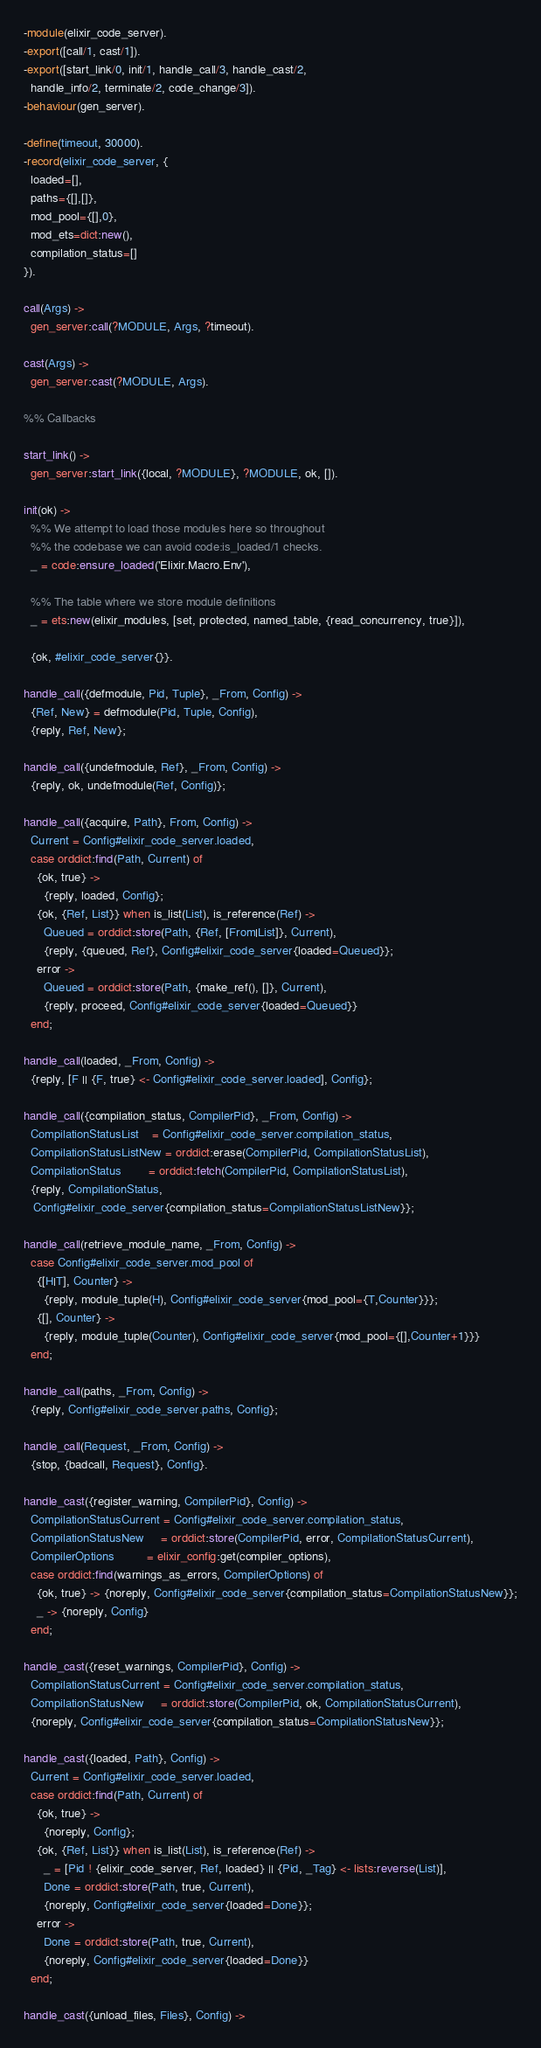Convert code to text. <code><loc_0><loc_0><loc_500><loc_500><_Erlang_>-module(elixir_code_server).
-export([call/1, cast/1]).
-export([start_link/0, init/1, handle_call/3, handle_cast/2,
  handle_info/2, terminate/2, code_change/3]).
-behaviour(gen_server).

-define(timeout, 30000).
-record(elixir_code_server, {
  loaded=[],
  paths={[],[]},
  mod_pool={[],0},
  mod_ets=dict:new(),
  compilation_status=[]
}).

call(Args) ->
  gen_server:call(?MODULE, Args, ?timeout).

cast(Args) ->
  gen_server:cast(?MODULE, Args).

%% Callbacks

start_link() ->
  gen_server:start_link({local, ?MODULE}, ?MODULE, ok, []).

init(ok) ->
  %% We attempt to load those modules here so throughout
  %% the codebase we can avoid code:is_loaded/1 checks.
  _ = code:ensure_loaded('Elixir.Macro.Env'),

  %% The table where we store module definitions
  _ = ets:new(elixir_modules, [set, protected, named_table, {read_concurrency, true}]),

  {ok, #elixir_code_server{}}.

handle_call({defmodule, Pid, Tuple}, _From, Config) ->
  {Ref, New} = defmodule(Pid, Tuple, Config),
  {reply, Ref, New};

handle_call({undefmodule, Ref}, _From, Config) ->
  {reply, ok, undefmodule(Ref, Config)};

handle_call({acquire, Path}, From, Config) ->
  Current = Config#elixir_code_server.loaded,
  case orddict:find(Path, Current) of
    {ok, true} ->
      {reply, loaded, Config};
    {ok, {Ref, List}} when is_list(List), is_reference(Ref) ->
      Queued = orddict:store(Path, {Ref, [From|List]}, Current),
      {reply, {queued, Ref}, Config#elixir_code_server{loaded=Queued}};
    error ->
      Queued = orddict:store(Path, {make_ref(), []}, Current),
      {reply, proceed, Config#elixir_code_server{loaded=Queued}}
  end;

handle_call(loaded, _From, Config) ->
  {reply, [F || {F, true} <- Config#elixir_code_server.loaded], Config};

handle_call({compilation_status, CompilerPid}, _From, Config) ->
  CompilationStatusList    = Config#elixir_code_server.compilation_status,
  CompilationStatusListNew = orddict:erase(CompilerPid, CompilationStatusList),
  CompilationStatus        = orddict:fetch(CompilerPid, CompilationStatusList),
  {reply, CompilationStatus,
   Config#elixir_code_server{compilation_status=CompilationStatusListNew}};

handle_call(retrieve_module_name, _From, Config) ->
  case Config#elixir_code_server.mod_pool of
    {[H|T], Counter} ->
      {reply, module_tuple(H), Config#elixir_code_server{mod_pool={T,Counter}}};
    {[], Counter} ->
      {reply, module_tuple(Counter), Config#elixir_code_server{mod_pool={[],Counter+1}}}
  end;

handle_call(paths, _From, Config) ->
  {reply, Config#elixir_code_server.paths, Config};

handle_call(Request, _From, Config) ->
  {stop, {badcall, Request}, Config}.

handle_cast({register_warning, CompilerPid}, Config) ->
  CompilationStatusCurrent = Config#elixir_code_server.compilation_status,
  CompilationStatusNew     = orddict:store(CompilerPid, error, CompilationStatusCurrent),
  CompilerOptions          = elixir_config:get(compiler_options),
  case orddict:find(warnings_as_errors, CompilerOptions) of
    {ok, true} -> {noreply, Config#elixir_code_server{compilation_status=CompilationStatusNew}};
    _ -> {noreply, Config}
  end;

handle_cast({reset_warnings, CompilerPid}, Config) ->
  CompilationStatusCurrent = Config#elixir_code_server.compilation_status,
  CompilationStatusNew     = orddict:store(CompilerPid, ok, CompilationStatusCurrent),
  {noreply, Config#elixir_code_server{compilation_status=CompilationStatusNew}};

handle_cast({loaded, Path}, Config) ->
  Current = Config#elixir_code_server.loaded,
  case orddict:find(Path, Current) of
    {ok, true} ->
      {noreply, Config};
    {ok, {Ref, List}} when is_list(List), is_reference(Ref) ->
      _ = [Pid ! {elixir_code_server, Ref, loaded} || {Pid, _Tag} <- lists:reverse(List)],
      Done = orddict:store(Path, true, Current),
      {noreply, Config#elixir_code_server{loaded=Done}};
    error ->
      Done = orddict:store(Path, true, Current),
      {noreply, Config#elixir_code_server{loaded=Done}}
  end;

handle_cast({unload_files, Files}, Config) -></code> 